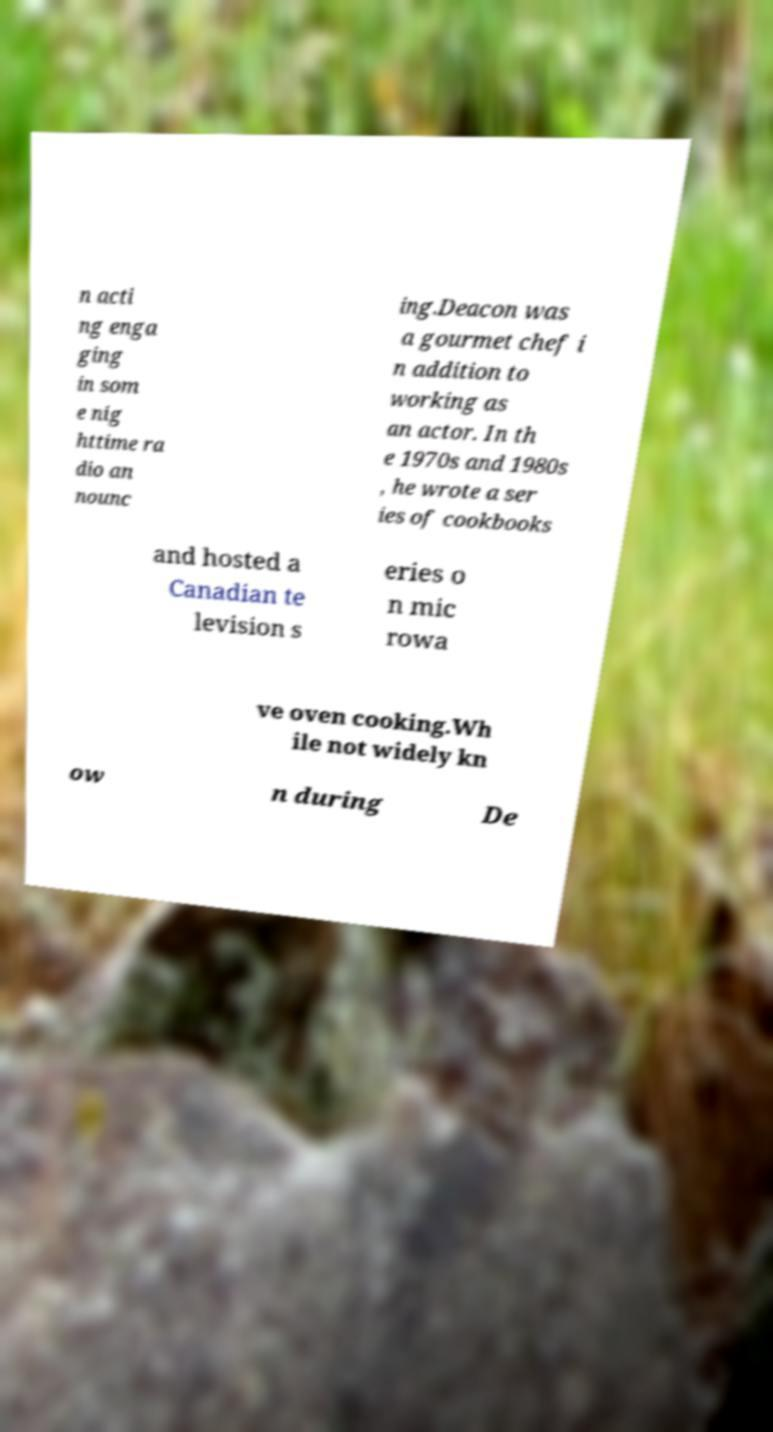What messages or text are displayed in this image? I need them in a readable, typed format. n acti ng enga ging in som e nig httime ra dio an nounc ing.Deacon was a gourmet chef i n addition to working as an actor. In th e 1970s and 1980s , he wrote a ser ies of cookbooks and hosted a Canadian te levision s eries o n mic rowa ve oven cooking.Wh ile not widely kn ow n during De 